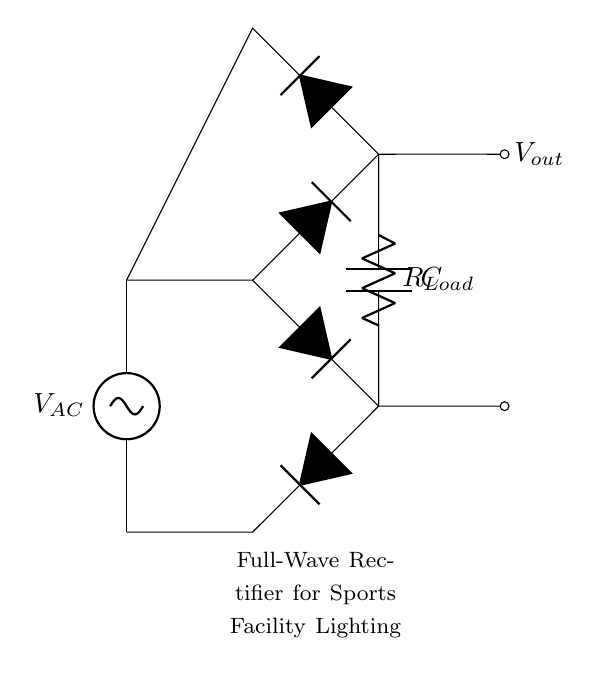What is the purpose of the capacitor in this circuit? The capacitor smooths the output voltage by filtering any ripple that comes from the rectification process. This is crucial for providing a consistent illumination in lighting systems, ensuring the lights do not flicker.
Answer: Smoothing What type of rectifier is represented in the circuit? The circuit diagram depicts a full-wave rectifier, which utilizes diodes to convert both halves of the AC waveform into DC. This is achieved by the arrangement of the diodes in a bridge configuration.
Answer: Full-wave What is the role of the load resistor in this circuit? The load resistor provides a path for the current to flow, simulating the lighting system's resistance. It essentially represents the load being powered by the rectified output, which is vital for understanding the circuit's performance.
Answer: Load How many diodes are used in the full-wave rectifier? The diagram illustrates a total of four diodes arranged in a bridge configuration, which collectively allow for the conduction of current during both halves of the AC cycle, enhancing efficiency.
Answer: Four What is the output voltage in relation to the input AC voltage? The output voltage in a full-wave rectifier is approximately equal to the peak input AC voltage minus the diode forward voltage drops, typically leading to a higher DC voltage than that of a half-wave rectifier.
Answer: Peak minus diode drops What happens to the current when the AC voltage passes through the rectifier? The current flows in a unidirectional manner after it passes through the rectifier due to the diodes allowing conduction only when the voltage is above a certain threshold, thereby ensuring a steady flow necessary for consistent illumination.
Answer: Unidirectional 